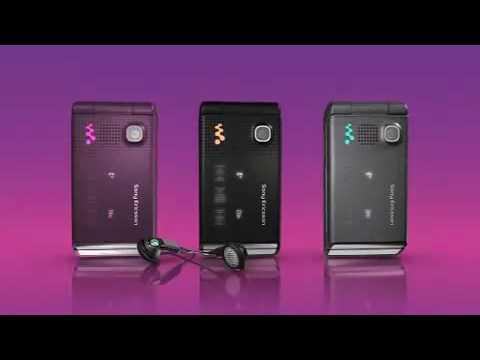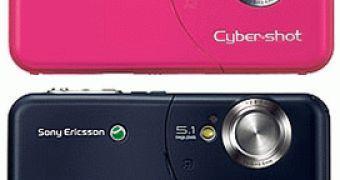The first image is the image on the left, the second image is the image on the right. For the images shown, is this caption "There is an open flip phone in the image on the left." true? Answer yes or no. No. The first image is the image on the left, the second image is the image on the right. Examine the images to the left and right. Is the description "Exactly one flip phone is open." accurate? Answer yes or no. No. 